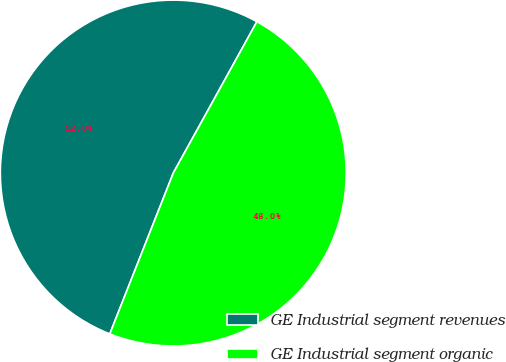Convert chart. <chart><loc_0><loc_0><loc_500><loc_500><pie_chart><fcel>GE Industrial segment revenues<fcel>GE Industrial segment organic<nl><fcel>52.05%<fcel>47.95%<nl></chart> 